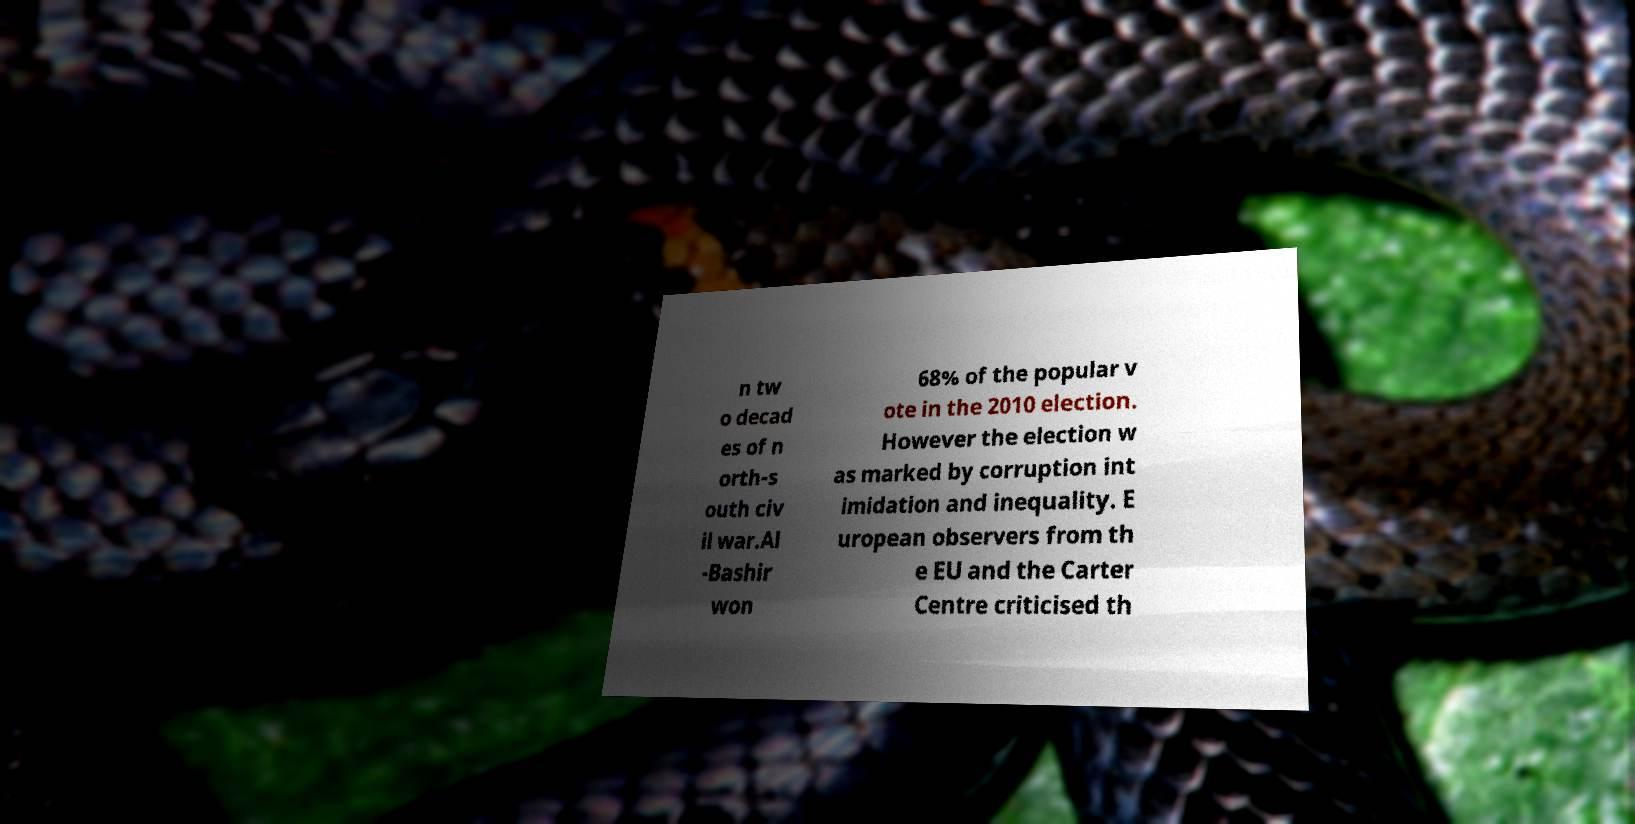Please identify and transcribe the text found in this image. n tw o decad es of n orth-s outh civ il war.Al -Bashir won 68% of the popular v ote in the 2010 election. However the election w as marked by corruption int imidation and inequality. E uropean observers from th e EU and the Carter Centre criticised th 